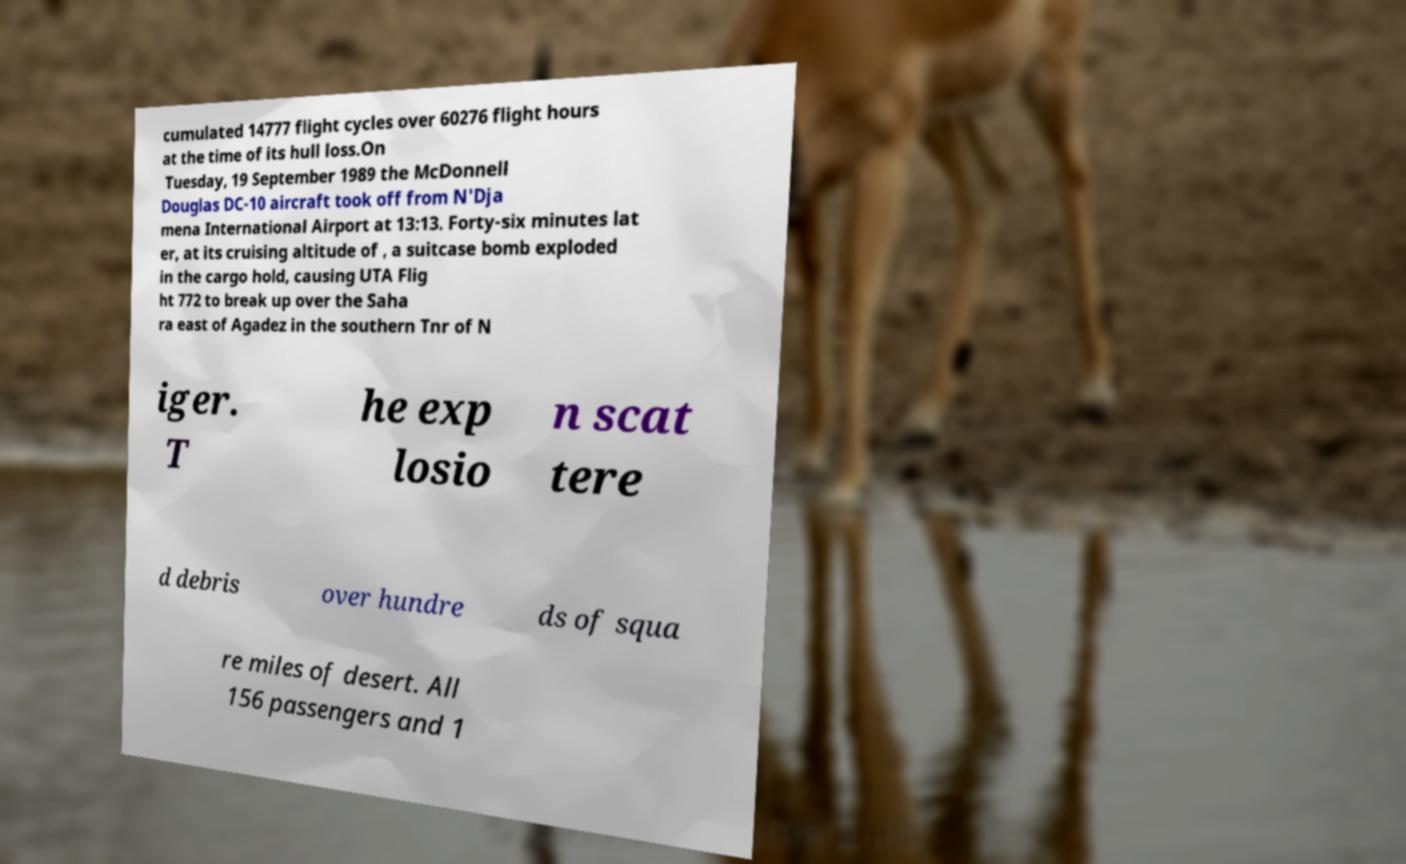Could you assist in decoding the text presented in this image and type it out clearly? cumulated 14777 flight cycles over 60276 flight hours at the time of its hull loss.On Tuesday, 19 September 1989 the McDonnell Douglas DC-10 aircraft took off from N'Dja mena International Airport at 13:13. Forty-six minutes lat er, at its cruising altitude of , a suitcase bomb exploded in the cargo hold, causing UTA Flig ht 772 to break up over the Saha ra east of Agadez in the southern Tnr of N iger. T he exp losio n scat tere d debris over hundre ds of squa re miles of desert. All 156 passengers and 1 